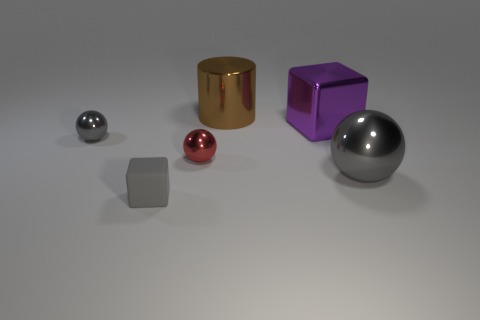Can you tell me which object in the picture is the largest? Certainly! The largest object in the image appears to be the silver metallic sphere. Its size is noticeably greater than the other items present. 